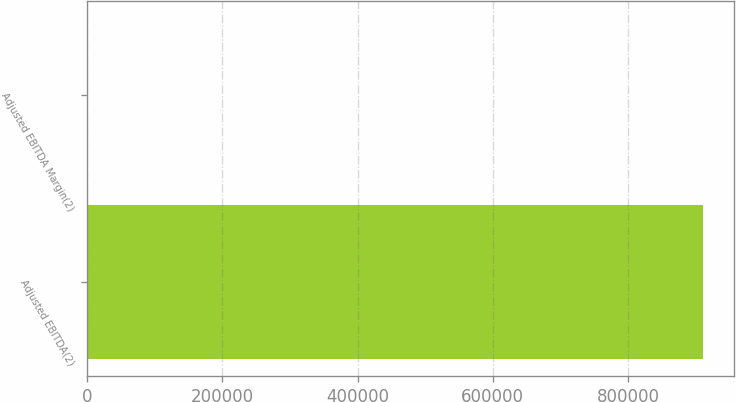Convert chart. <chart><loc_0><loc_0><loc_500><loc_500><bar_chart><fcel>Adjusted EBITDA(2)<fcel>Adjusted EBITDA Margin(2)<nl><fcel>910917<fcel>30.3<nl></chart> 